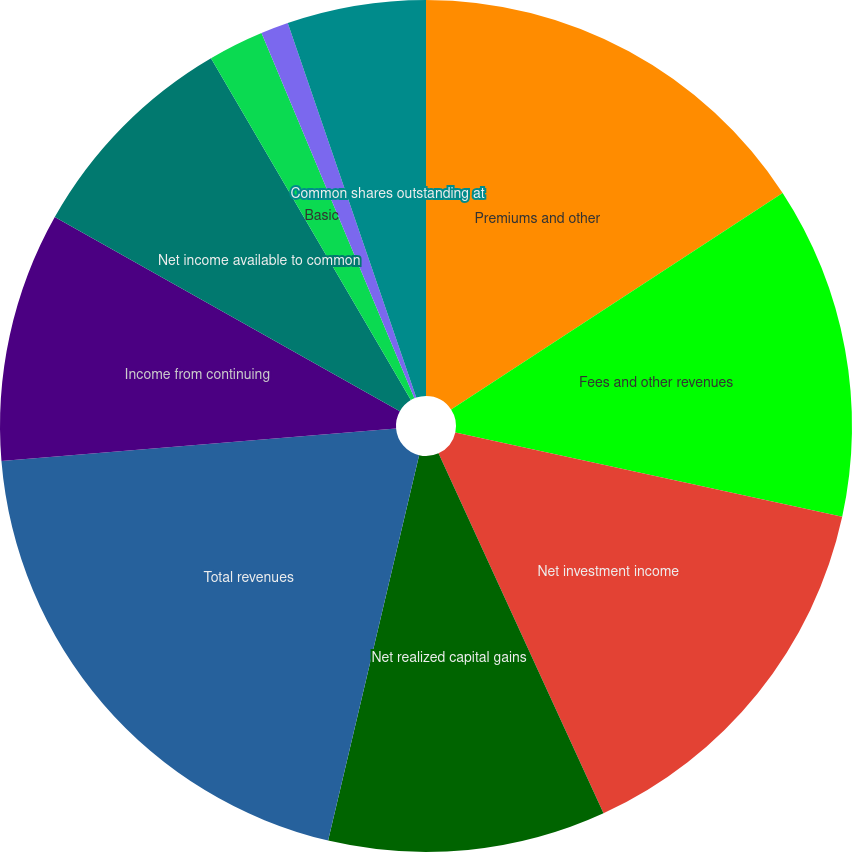Convert chart to OTSL. <chart><loc_0><loc_0><loc_500><loc_500><pie_chart><fcel>Premiums and other<fcel>Fees and other revenues<fcel>Net investment income<fcel>Net realized capital gains<fcel>Total revenues<fcel>Income from continuing<fcel>Net income available to common<fcel>Basic<fcel>Diluted<fcel>Common shares outstanding at<nl><fcel>15.79%<fcel>12.63%<fcel>14.74%<fcel>10.53%<fcel>20.0%<fcel>9.47%<fcel>8.42%<fcel>2.11%<fcel>1.05%<fcel>5.26%<nl></chart> 